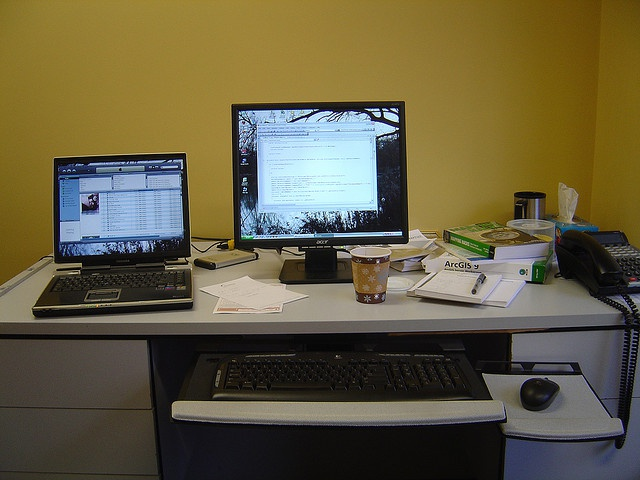Describe the objects in this image and their specific colors. I can see tv in olive, black, and lightblue tones, laptop in olive, black, lightblue, and gray tones, keyboard in olive, black, darkgreen, and gray tones, book in olive, darkgray, darkgreen, and gray tones, and book in olive, darkgray, black, gray, and darkgreen tones in this image. 